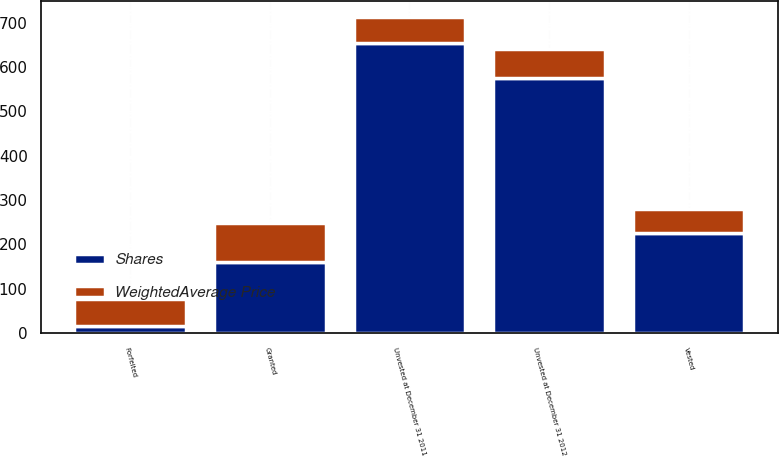Convert chart. <chart><loc_0><loc_0><loc_500><loc_500><stacked_bar_chart><ecel><fcel>Unvested at December 31 2011<fcel>Granted<fcel>Vested<fcel>Forfeited<fcel>Unvested at December 31 2012<nl><fcel>Shares<fcel>654<fcel>161<fcel>225<fcel>16<fcel>574<nl><fcel>WeightedAverage Price<fcel>57.94<fcel>87.81<fcel>55.21<fcel>61.83<fcel>67.28<nl></chart> 